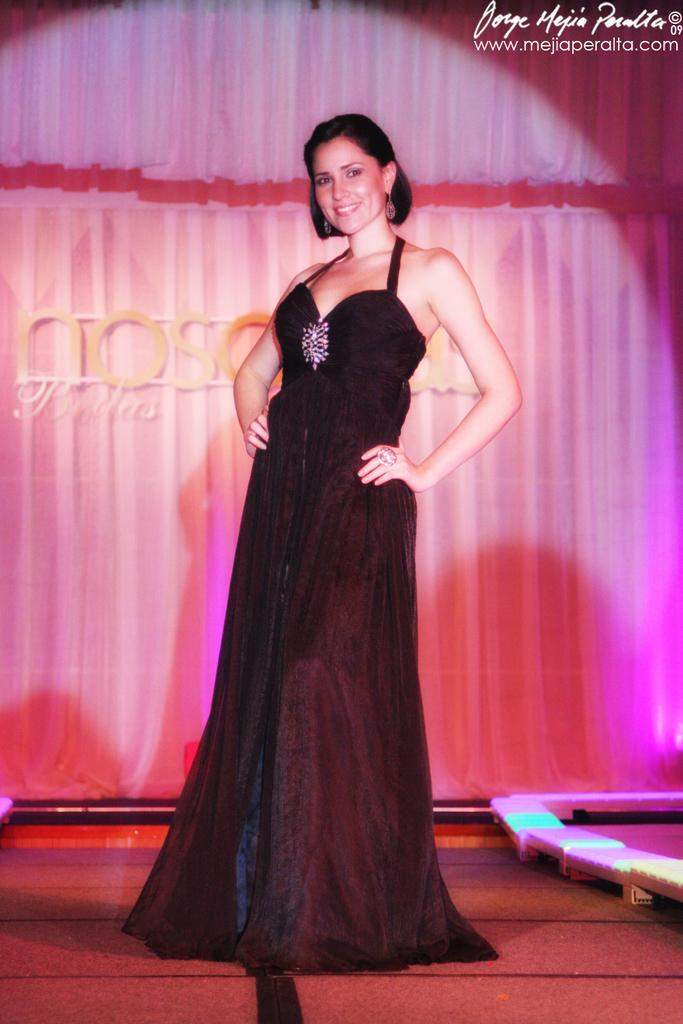Who is the main subject in the image? There is a woman standing in the center of the image. What can be seen in the background of the image? There is a wall and curtains in the background of the image. What is visible at the bottom of the image? There is a floor visible at the bottom of the image. What type of eggnog is being whipped by the men in the image? There are no men or eggnog present in the image; it features a woman standing in the center. 